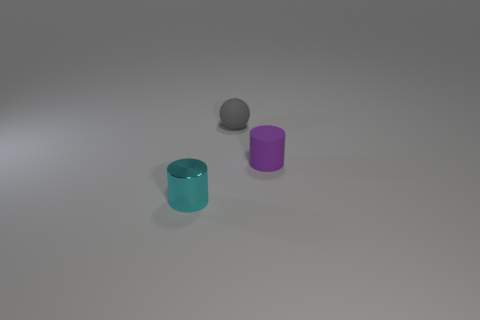If I'm looking at this as an art piece, what themes could I interpret from the arrangement of these objects? This arrangement can evoke themes of simplicity and contrast. The minimalism of only three objects allows for a focus on their shapes and colors. The contrast is found in their colors (teal, purple, and grey), their finishes (reflective and matte), and their placement relative to each other, suggesting themes about diversity or individuality within a unified space. 